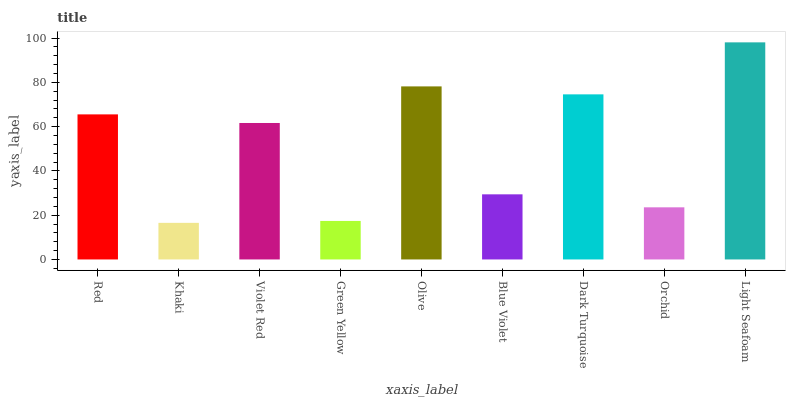Is Khaki the minimum?
Answer yes or no. Yes. Is Light Seafoam the maximum?
Answer yes or no. Yes. Is Violet Red the minimum?
Answer yes or no. No. Is Violet Red the maximum?
Answer yes or no. No. Is Violet Red greater than Khaki?
Answer yes or no. Yes. Is Khaki less than Violet Red?
Answer yes or no. Yes. Is Khaki greater than Violet Red?
Answer yes or no. No. Is Violet Red less than Khaki?
Answer yes or no. No. Is Violet Red the high median?
Answer yes or no. Yes. Is Violet Red the low median?
Answer yes or no. Yes. Is Green Yellow the high median?
Answer yes or no. No. Is Orchid the low median?
Answer yes or no. No. 